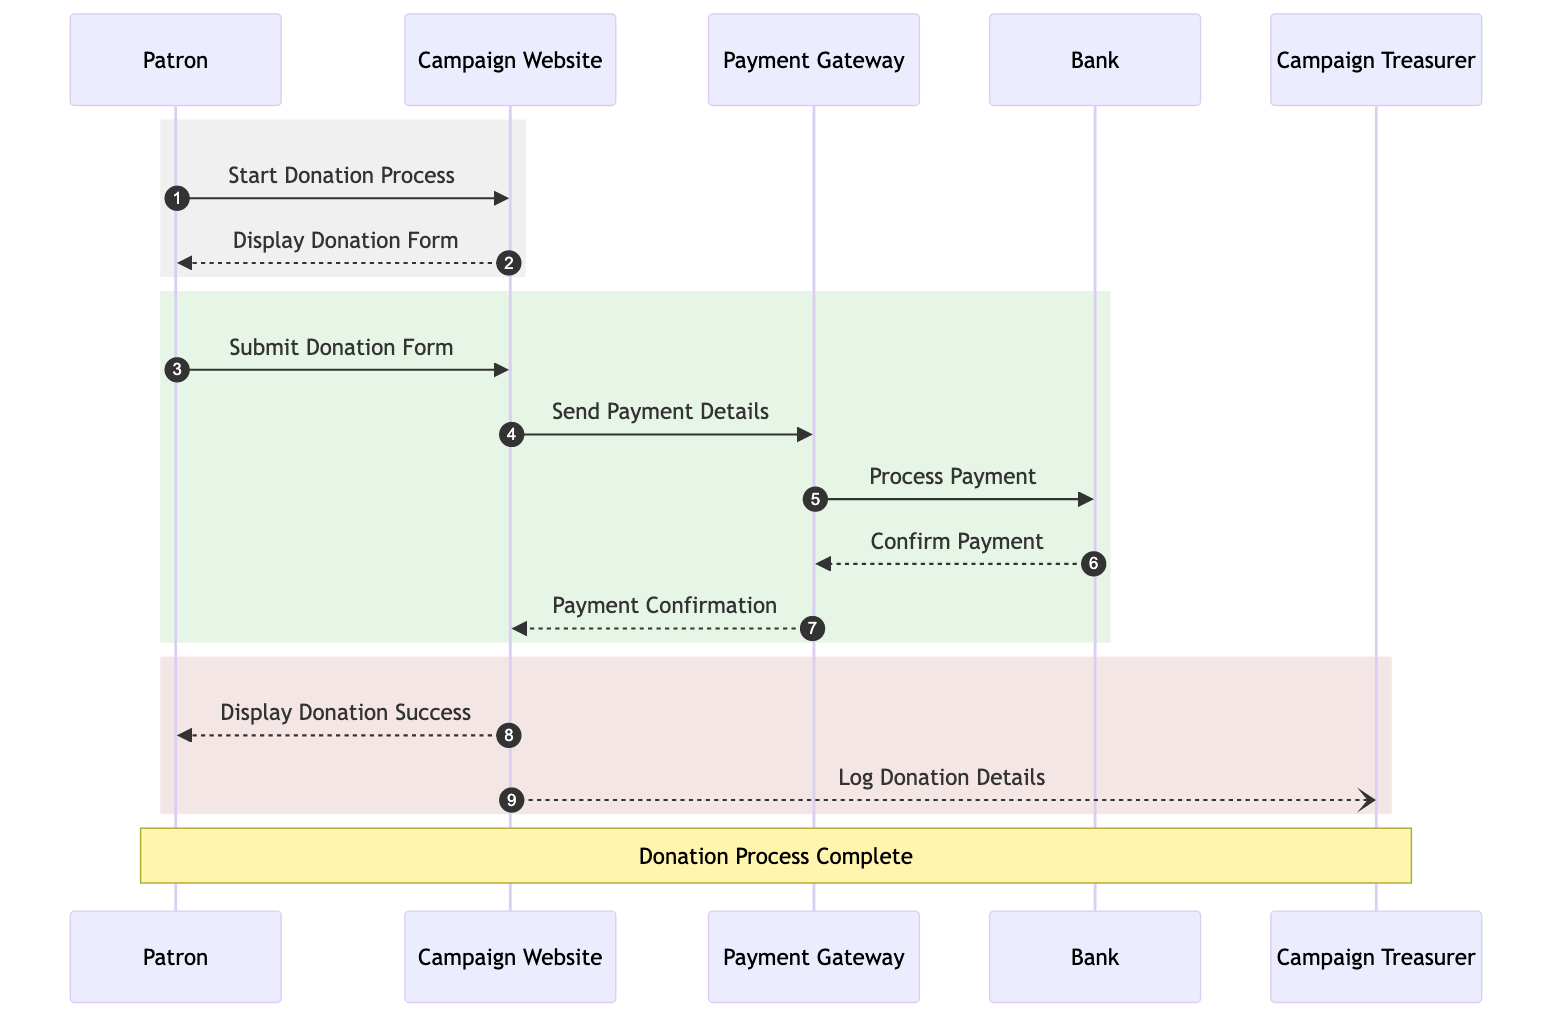What is the first action performed by the Patron? The Patron starts the donation process, as depicted by the arrow from Patron to Campaign Website labeled 'Start Donation Process'. This indicates the initiation of the donation sequence.
Answer: Start Donation Process How many participants are there in the diagram? There are five participants shown: Patron, Campaign Website, Payment Gateway, Bank, and Campaign Treasurer. Each has a distinct role in the donation process.
Answer: 5 What message does the Campaign Website send to the Patron after displaying the donation form? After displaying the donation form, the Campaign Website sends a response to the Patron labeled 'Display Donation Success', indicating that the donation was successful.
Answer: Display Donation Success Which participant is responsible for logging donation details? The Campaign Treasurer is responsible for logging donation details, as indicated by the notification from Campaign Website to Campaign Treasurer.
Answer: Campaign Treasurer What event occurs immediately after the Payment Gateway processes the payment? After the Payment Gateway processes the payment, it receives payment confirmation from the Bank, signifying that the payment has been completed successfully.
Answer: Confirm Payment What is the second message sent by the Patron? The second message sent by the Patron is to submit the donation form. This request follows the initial action of starting the donation process and is crucial for proceeding.
Answer: Submit Donation Form How many types of messages are involved in the donation process? There are two types of messages: requests and responses. This classification highlights the nature of interactions between different participants during the flow of the donation process.
Answer: 2 What does the Payment Gateway send back to the Campaign Website after confirming payment? The Payment Gateway sends back a payment confirmation to the Campaign Website after processing the payment. This step indicates that the payment has been successfully cleared.
Answer: Payment Confirmation Which message is sent first in the second rectangular section of the diagram? The first message in the second rectangular section sent is from the Patron to the Campaign Website, labeled 'Submit Donation Form', as it continues the sequence of actions required to complete the donation.
Answer: Submit Donation Form 